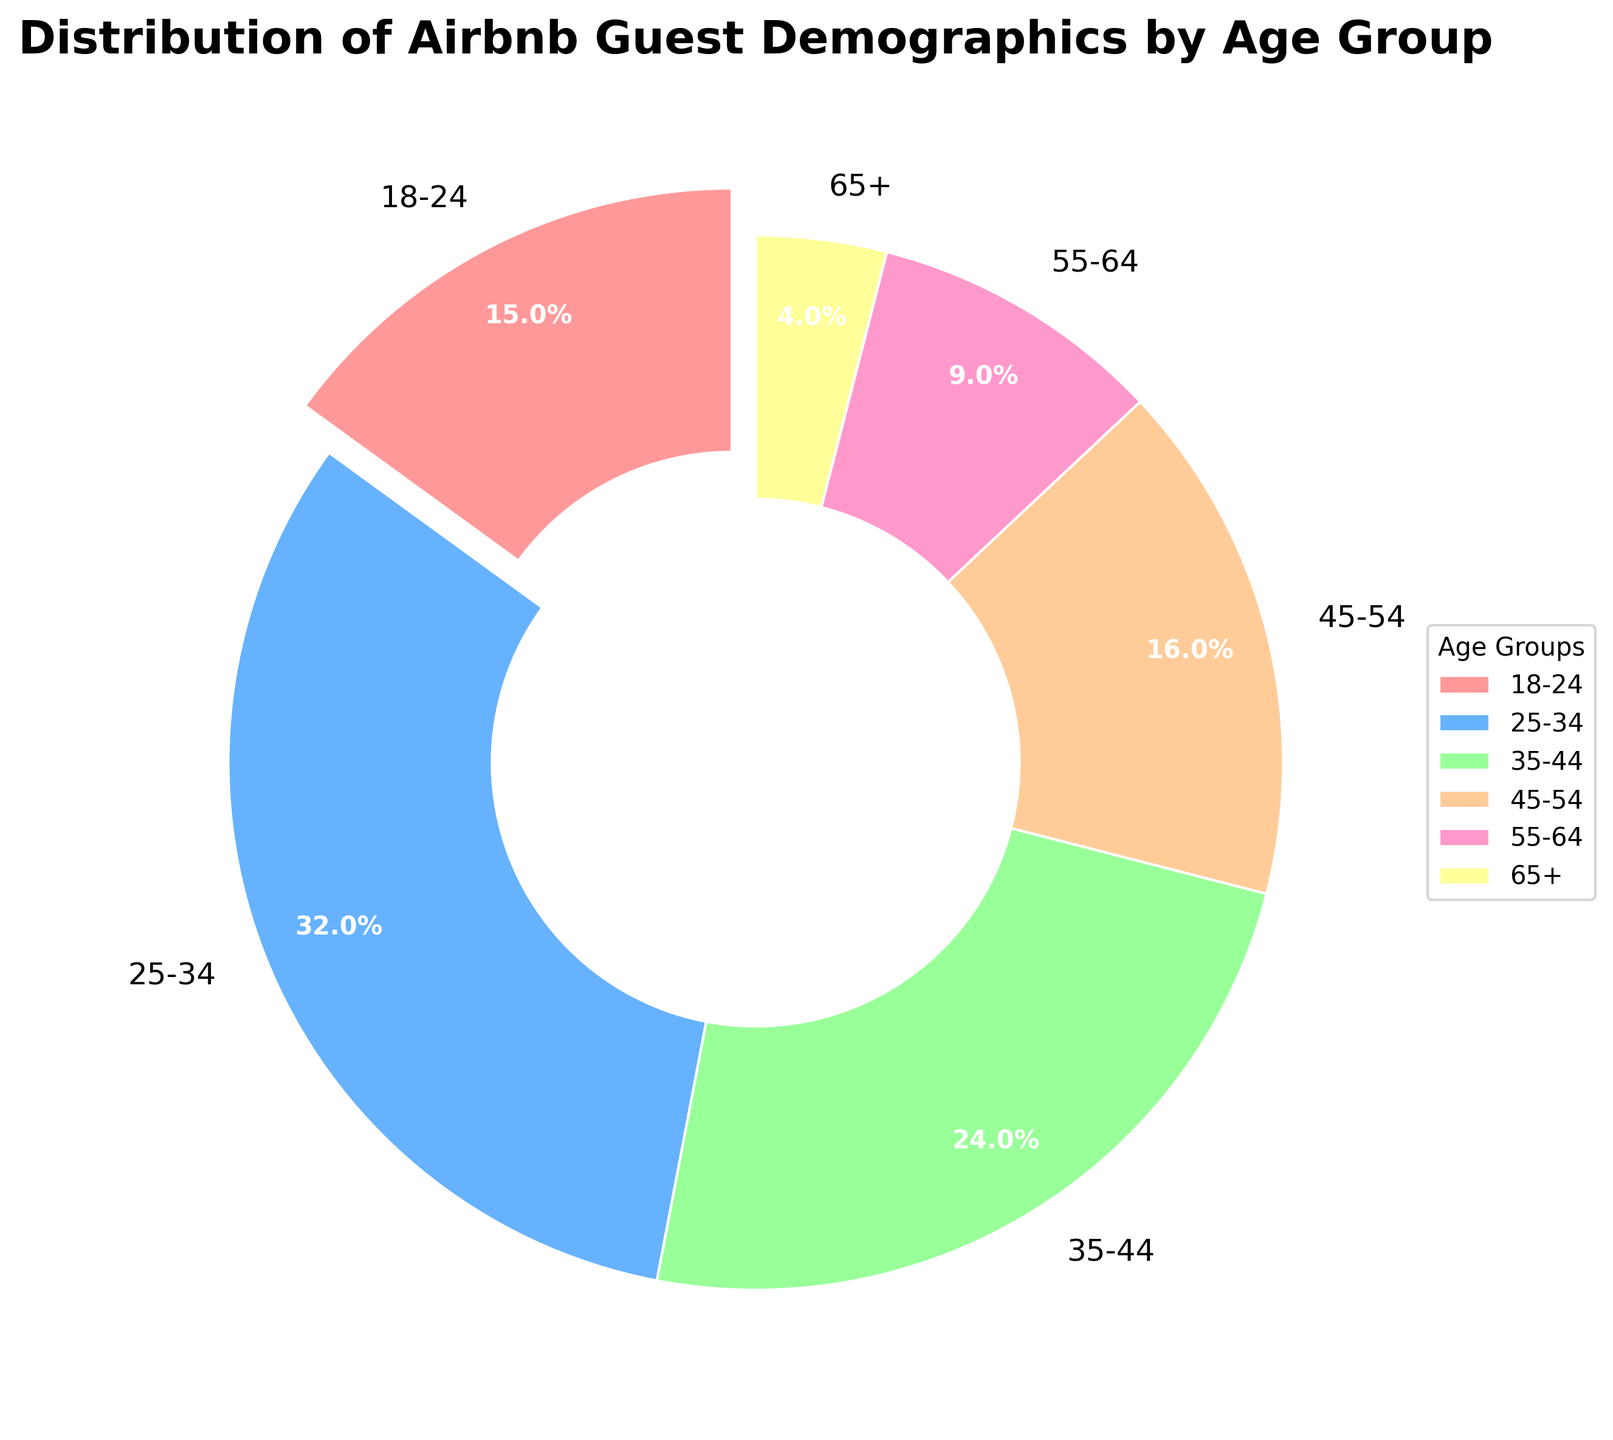Which age group has the largest percentage? The pie chart shows that the 25-34 age group has the largest segment. It occupies 32% of the total percentages, which is higher than any other group.
Answer: 25-34 Which two age groups together account for over half of the guests? According to the pie chart, the 25-34 age group is 32% and the 35-44 age group is 24%. Adding these together, 32% + 24% equals 56%, which is more than half.
Answer: 25-34 and 35-44 Which age group has the smallest percentage of guests? The 65+ age group is the smallest segment in the pie chart, making up only 4% of the total guests.
Answer: 65+ What percentage of guests are either between 18-24 or 55-64? The 18-24 age group is 15% and the 55-64 age group is 9%. Adding these together, 15% + 9% equals 24%.
Answer: 24% Is the percentage of guests aged 45-54 greater than those aged 18-24? The pie chart shows that the 45-54 age group accounts for 16% while the 18-24 age group accounts for 15%. Thus, 16% is indeed greater than 15%.
Answer: Yes What's the combined percentage of guests aged 45 and older? The groups in this range are 45-54 (16%), 55-64 (9%), and 65+ (4%). Adding these together, 16% + 9% + 4% equals 29%.
Answer: 29% How does the percentage of guests aged 35-44 compare to those aged 55-64? The 35-44 group makes up 24%, whereas the 55-64 group represents 9%. Thus, 24% is significantly higher than 9%.
Answer: 35-44 is higher Which color represents the 25-34 age group on the pie chart? The second age group segment, labeled 25-34, is represented by the color blue, which is the second color in the specified sequence.
Answer: Blue 